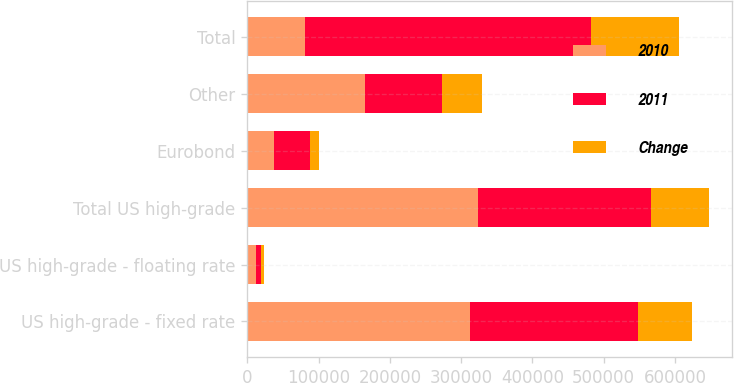Convert chart to OTSL. <chart><loc_0><loc_0><loc_500><loc_500><stacked_bar_chart><ecel><fcel>US high-grade - fixed rate<fcel>US high-grade - floating rate<fcel>Total US high-grade<fcel>Eurobond<fcel>Other<fcel>Total<nl><fcel>2010<fcel>311758<fcel>11802<fcel>323560<fcel>36933<fcel>164514<fcel>80164<nl><fcel>2011<fcel>235698<fcel>7698<fcel>243396<fcel>50251<fcel>108610<fcel>402257<nl><fcel>Change<fcel>76060<fcel>4104<fcel>80164<fcel>13318<fcel>55904<fcel>122750<nl></chart> 